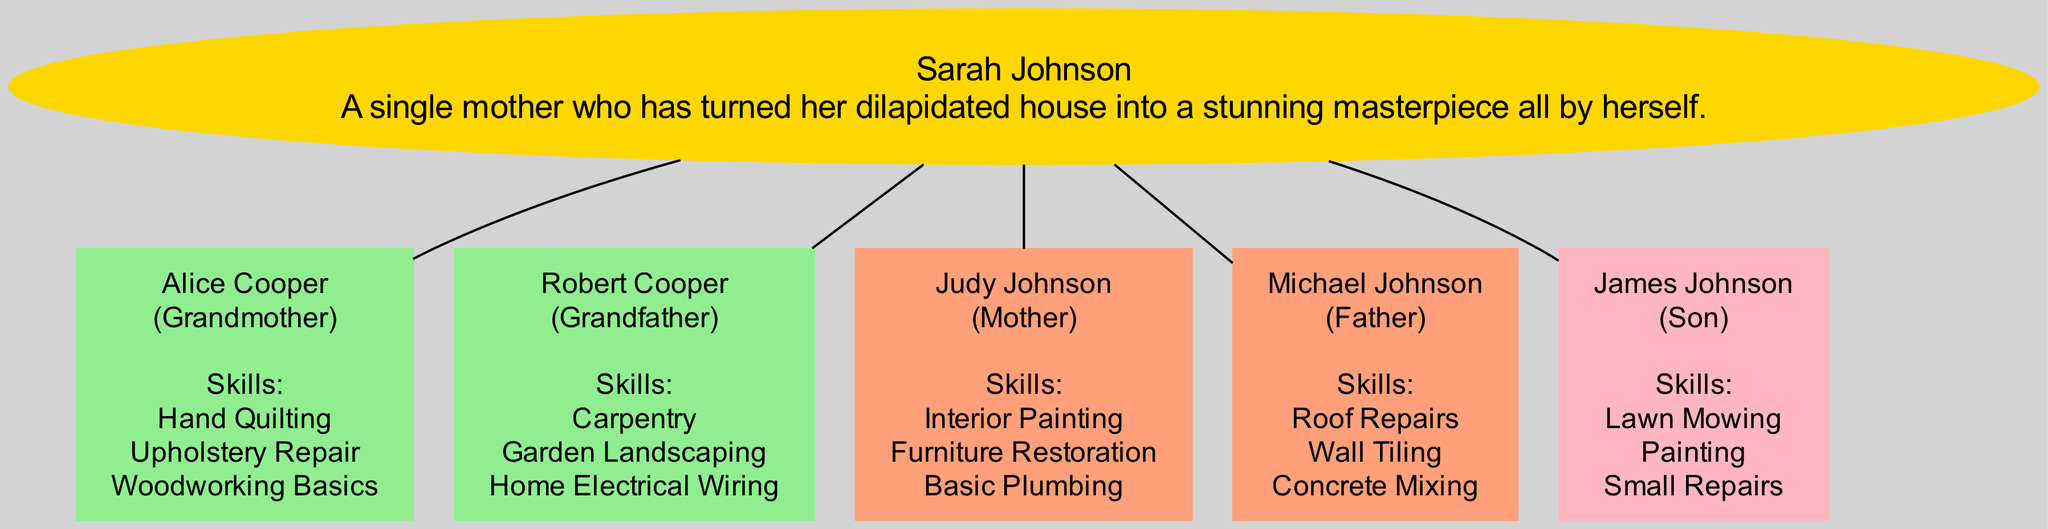What is the name of Sarah's grandfather? The diagram lists Sarah's family members, including their relations. Under the "Grandfather" category, the name provided is "Robert Cooper."
Answer: Robert Cooper How many skills did Sarah's mother list? The diagram shows the skills under the "Mother" category for Judy Johnson. She has three skills listed: "Interior Painting," "Furniture Restoration," and "Basic Plumbing." Therefore, the total number of skills is three.
Answer: 3 What skill is shared between Sarah and her son? To find the shared skill, we look at the skills listed for Sarah's son, James Johnson, which are "Lawn Mowing," "Painting," and "Small Repairs." Since Sarah is also shown to have "Painting" skills, this is the shared one.
Answer: Painting Who has skills in woodworking? The diagram indicates that Sarah's grandmother, Alice Cooper, has skills that include "Woodworking Basics." Therefore, Alice is the one with skills in woodworking.
Answer: Alice Cooper Which family member has skills related to home electrical work? According to the diagram, the skills associated with home electrical work are listed under Sarah's grandfather, Robert Cooper, specifically mentioned as "Home Electrical Wiring."
Answer: Robert Cooper How many generations are depicted in the family tree? The family tree diagram shows three generations: grandparents (Alice Cooper and Robert Cooper), parents (Judy Johnson and Michael Johnson), and Sarah and her son, James Johnson. This gives us three distinct generations.
Answer: 3 What is James Johnson's relation to Sarah? By examining the relationship shown in the diagram, James Johnson is identified as the "Son" of Sarah Johnson. Thus, the direct relationship is easily observable.
Answer: Son Which skill listed under Sarah's father's name involves concrete? The skills listed for Sarah's father, Michael Johnson, include "Concrete Mixing." This indicates the skill specifically related to concrete work.
Answer: Concrete Mixing 